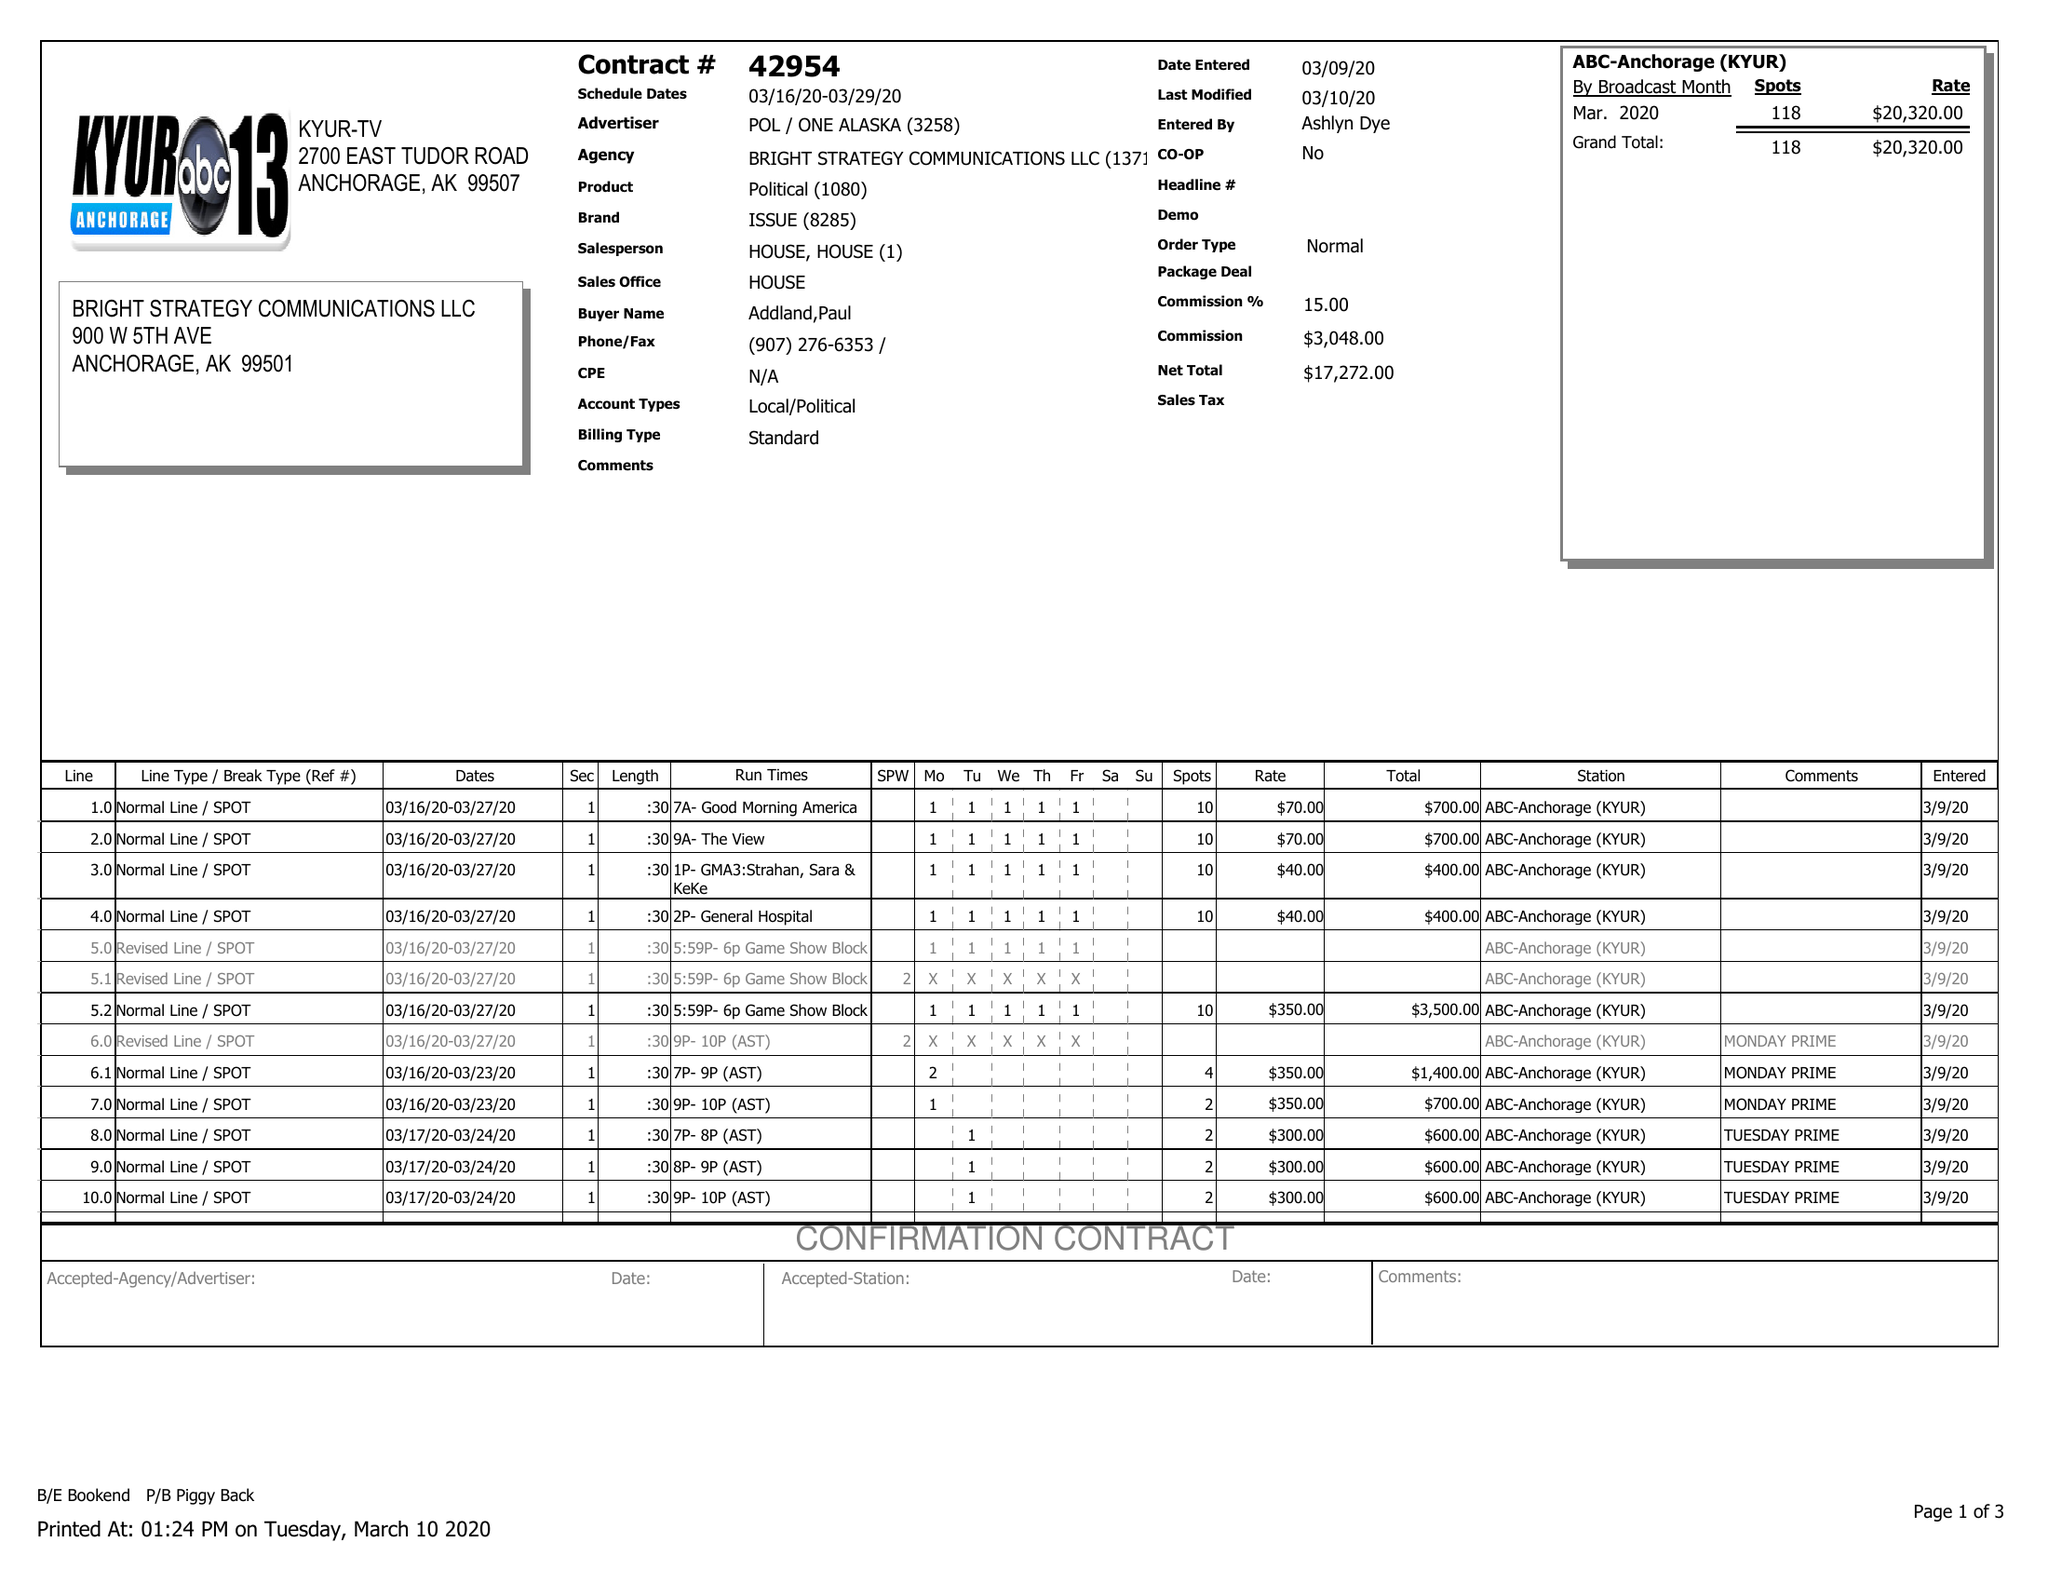What is the value for the contract_num?
Answer the question using a single word or phrase. 42954 